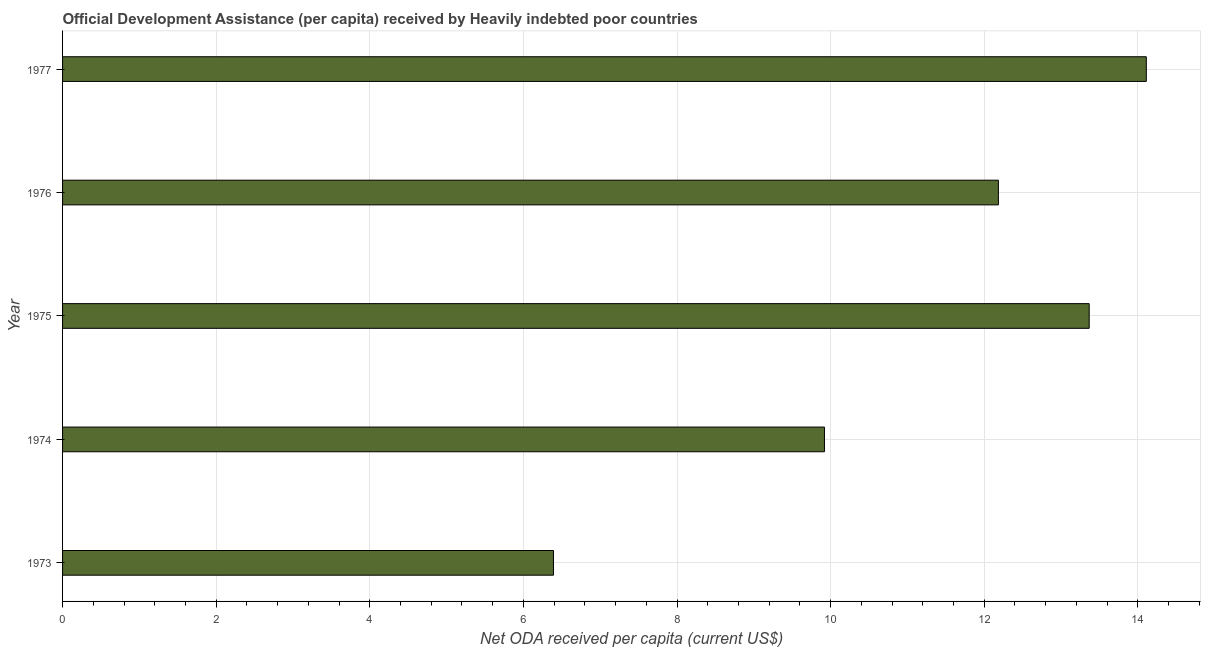Does the graph contain any zero values?
Keep it short and to the point. No. What is the title of the graph?
Offer a very short reply. Official Development Assistance (per capita) received by Heavily indebted poor countries. What is the label or title of the X-axis?
Offer a very short reply. Net ODA received per capita (current US$). What is the net oda received per capita in 1976?
Give a very brief answer. 12.18. Across all years, what is the maximum net oda received per capita?
Provide a short and direct response. 14.11. Across all years, what is the minimum net oda received per capita?
Your answer should be compact. 6.39. In which year was the net oda received per capita minimum?
Make the answer very short. 1973. What is the sum of the net oda received per capita?
Offer a terse response. 55.97. What is the difference between the net oda received per capita in 1975 and 1977?
Your response must be concise. -0.74. What is the average net oda received per capita per year?
Your answer should be compact. 11.19. What is the median net oda received per capita?
Give a very brief answer. 12.18. In how many years, is the net oda received per capita greater than 8.8 US$?
Your answer should be very brief. 4. Do a majority of the years between 1976 and 1975 (inclusive) have net oda received per capita greater than 5.2 US$?
Offer a very short reply. No. What is the ratio of the net oda received per capita in 1975 to that in 1977?
Your answer should be compact. 0.95. Is the difference between the net oda received per capita in 1975 and 1976 greater than the difference between any two years?
Your answer should be compact. No. What is the difference between the highest and the second highest net oda received per capita?
Keep it short and to the point. 0.74. Is the sum of the net oda received per capita in 1974 and 1977 greater than the maximum net oda received per capita across all years?
Your response must be concise. Yes. What is the difference between the highest and the lowest net oda received per capita?
Provide a succinct answer. 7.72. In how many years, is the net oda received per capita greater than the average net oda received per capita taken over all years?
Offer a very short reply. 3. What is the difference between two consecutive major ticks on the X-axis?
Make the answer very short. 2. Are the values on the major ticks of X-axis written in scientific E-notation?
Offer a terse response. No. What is the Net ODA received per capita (current US$) of 1973?
Provide a succinct answer. 6.39. What is the Net ODA received per capita (current US$) in 1974?
Provide a succinct answer. 9.92. What is the Net ODA received per capita (current US$) of 1975?
Your answer should be very brief. 13.37. What is the Net ODA received per capita (current US$) of 1976?
Make the answer very short. 12.18. What is the Net ODA received per capita (current US$) in 1977?
Ensure brevity in your answer.  14.11. What is the difference between the Net ODA received per capita (current US$) in 1973 and 1974?
Offer a very short reply. -3.53. What is the difference between the Net ODA received per capita (current US$) in 1973 and 1975?
Provide a succinct answer. -6.98. What is the difference between the Net ODA received per capita (current US$) in 1973 and 1976?
Provide a succinct answer. -5.79. What is the difference between the Net ODA received per capita (current US$) in 1973 and 1977?
Your response must be concise. -7.72. What is the difference between the Net ODA received per capita (current US$) in 1974 and 1975?
Make the answer very short. -3.45. What is the difference between the Net ODA received per capita (current US$) in 1974 and 1976?
Ensure brevity in your answer.  -2.26. What is the difference between the Net ODA received per capita (current US$) in 1974 and 1977?
Your response must be concise. -4.19. What is the difference between the Net ODA received per capita (current US$) in 1975 and 1976?
Your answer should be very brief. 1.18. What is the difference between the Net ODA received per capita (current US$) in 1975 and 1977?
Your answer should be very brief. -0.74. What is the difference between the Net ODA received per capita (current US$) in 1976 and 1977?
Offer a very short reply. -1.93. What is the ratio of the Net ODA received per capita (current US$) in 1973 to that in 1974?
Offer a terse response. 0.64. What is the ratio of the Net ODA received per capita (current US$) in 1973 to that in 1975?
Make the answer very short. 0.48. What is the ratio of the Net ODA received per capita (current US$) in 1973 to that in 1976?
Make the answer very short. 0.53. What is the ratio of the Net ODA received per capita (current US$) in 1973 to that in 1977?
Offer a terse response. 0.45. What is the ratio of the Net ODA received per capita (current US$) in 1974 to that in 1975?
Offer a very short reply. 0.74. What is the ratio of the Net ODA received per capita (current US$) in 1974 to that in 1976?
Ensure brevity in your answer.  0.81. What is the ratio of the Net ODA received per capita (current US$) in 1974 to that in 1977?
Your answer should be very brief. 0.7. What is the ratio of the Net ODA received per capita (current US$) in 1975 to that in 1976?
Give a very brief answer. 1.1. What is the ratio of the Net ODA received per capita (current US$) in 1975 to that in 1977?
Your answer should be compact. 0.95. What is the ratio of the Net ODA received per capita (current US$) in 1976 to that in 1977?
Offer a very short reply. 0.86. 